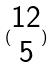<formula> <loc_0><loc_0><loc_500><loc_500>( \begin{matrix} 1 2 \\ 5 \end{matrix} )</formula> 